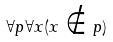<formula> <loc_0><loc_0><loc_500><loc_500>\forall p \forall x ( x \notin p )</formula> 